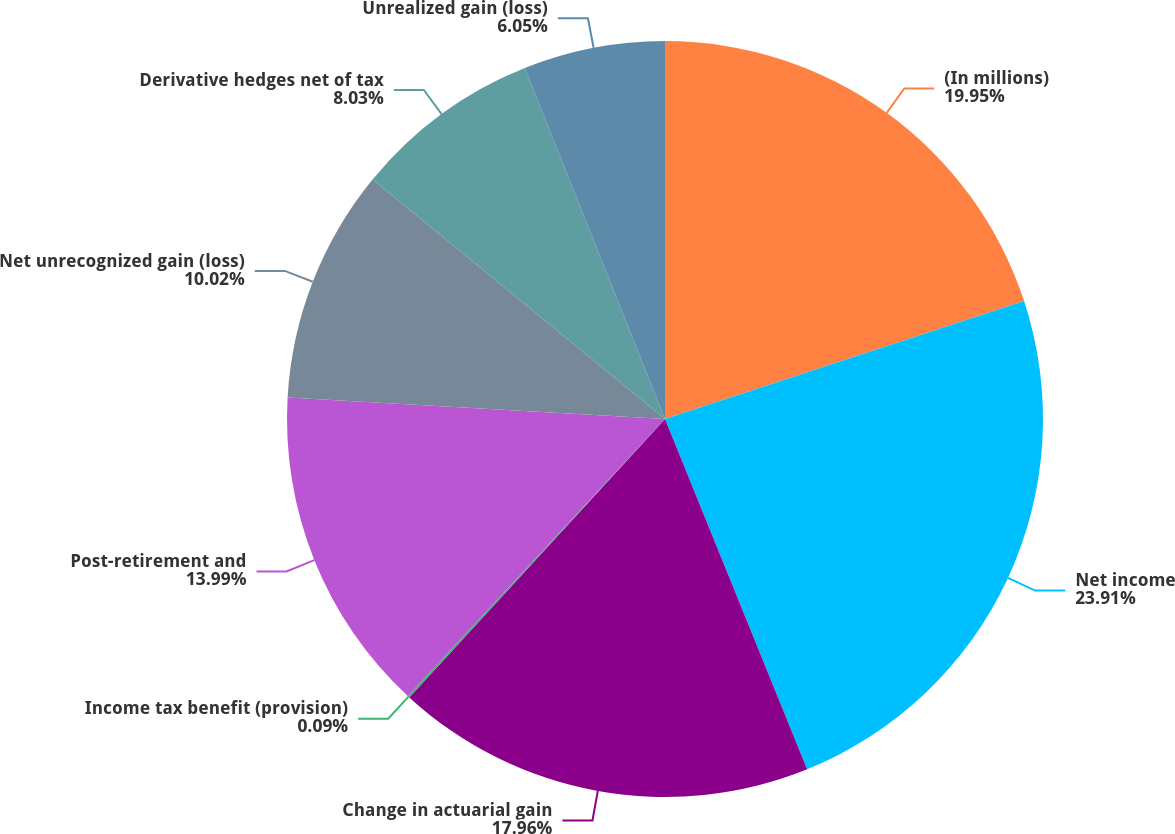Convert chart to OTSL. <chart><loc_0><loc_0><loc_500><loc_500><pie_chart><fcel>(In millions)<fcel>Net income<fcel>Change in actuarial gain<fcel>Income tax benefit (provision)<fcel>Post-retirement and<fcel>Net unrecognized gain (loss)<fcel>Derivative hedges net of tax<fcel>Unrealized gain (loss)<nl><fcel>19.95%<fcel>23.92%<fcel>17.96%<fcel>0.09%<fcel>13.99%<fcel>10.02%<fcel>8.03%<fcel>6.05%<nl></chart> 